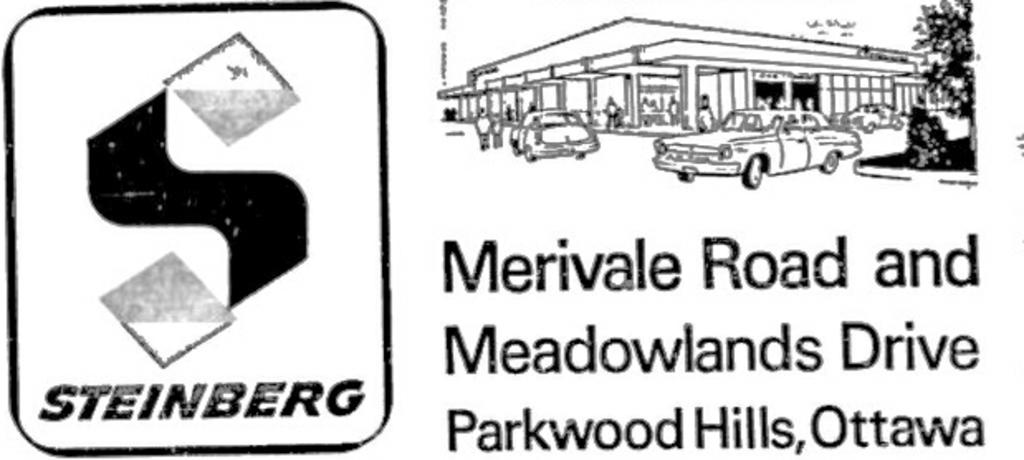What is present in the image that features visual content? There is a poster in the image. What can be seen on the poster? There are pictures on the poster. What else is present on the poster besides images? There is text on the poster. Is there any branding or identification on the poster? Yes, there is a logo on the poster. What type of shoe is featured in the image? There is no shoe present in the image; it features a poster with pictures, text, and a logo. Is there a sweater covering the logo on the poster? There is no sweater present in the image, as it only features a poster with various elements. 